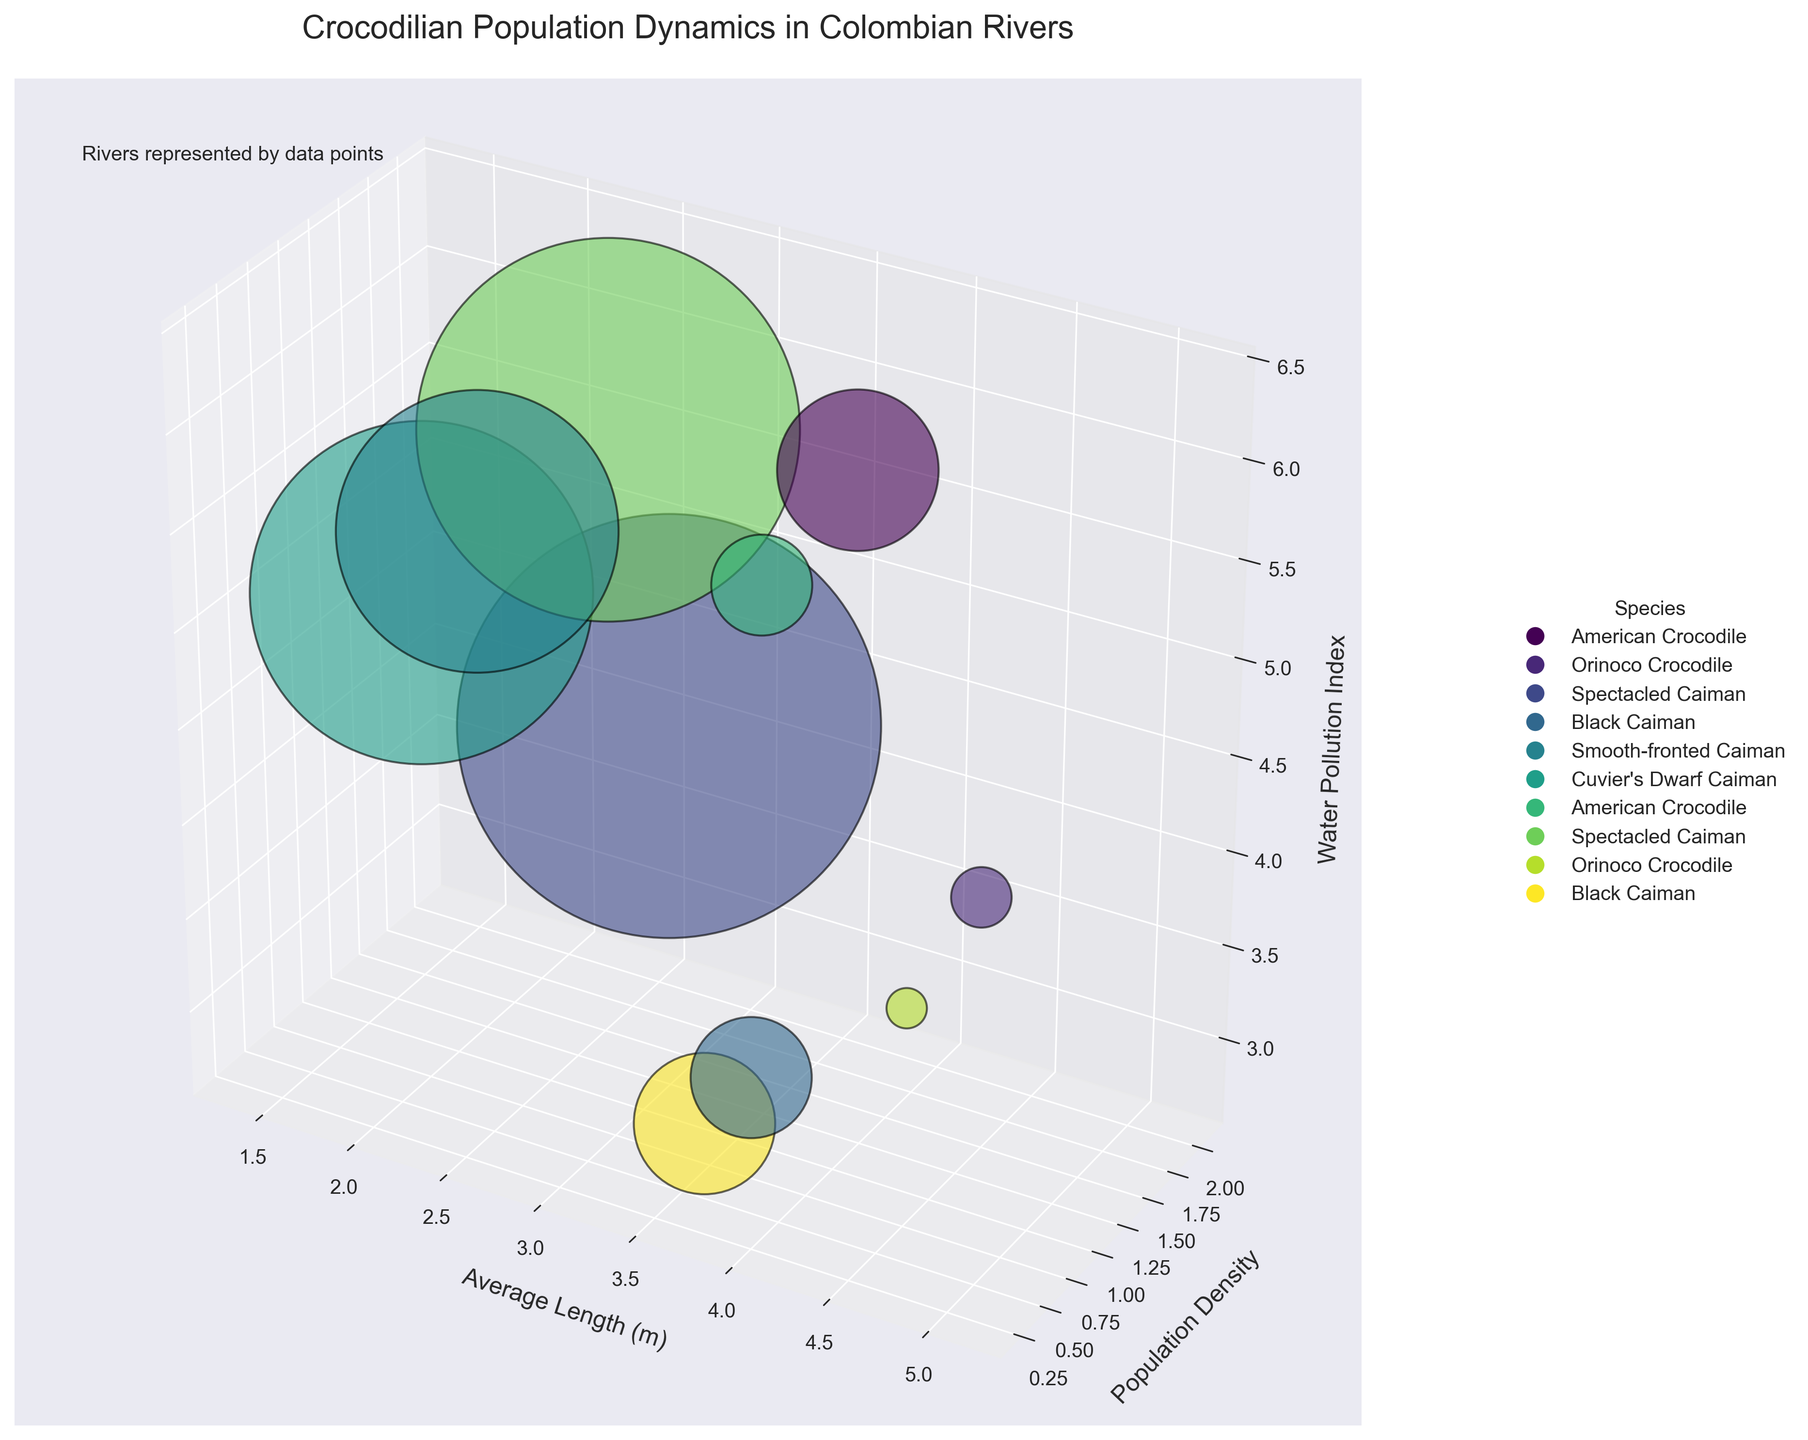What's the title of the figure? The title is located at the top of the figure. It reads "Crocodilian Population Dynamics in Colombian Rivers."
Answer: Crocodilian Population Dynamics in Colombian Rivers How many different species are represented in the figure? By looking at the legend, there are different markers for different species. Counting these gives us the answer.
Answer: 6 Which river has the highest population density of crocodilians? Identify the highest point on the Y-axis (Population Density) and check the corresponding river. The river with a maximum Y value of 2.1 is the Amazonas River.
Answer: Amazonas River Which species has the largest average length, and what is it? Look at the X-axis (Average Length). The maximum point, represented by dots, corresponds to the Orinoco Crocodile. The value is 5.1 meters.
Answer: Orinoco Crocodile, 5.1 meters Compare the population density of the Spectacled Caiman in the Amazonas River and the Atrato River. Which has a higher population density? Locate the Spectacled Caiman's data points for both rivers on the Y-axis and compare them. The Amazonas River has a population density of 2.1, and the Atrato River has 1.9, so the Amazonas River is higher.
Answer: Amazonas River Which two rivers have the lowest water pollution levels? Locate the points along the Z-axis (Water Pollution Index) and identify the lowest values. The values are 2.8 for the Apaporis River and 3.2 for the Caquetá River.
Answer: Apaporis River and Caquetá River If you compare the American Crocodile in the Magdalena River and the Sinú River, which one has a higher water pollution index and by how much? Check the Z-axis values for the Magdalena River and the Sinú River. Magdalena River has 6.3, and Sinú River has 5.8. Subtracting gives 0.5.
Answer: Magdalena River, 0.5 Which species is generally found in rivers with lower pollution indices, and what evidence supports your answer? Analyze the Z-axis (Water Pollution Index) focusing on the species distribution. The Black Caiman is found in Caquetá River (3.2) and Apaporis River (2.8), the lowest indices. This suggests this species favors less polluted rivers.
Answer: Black Caiman Sum up the population densities of Cuvier's Dwarf Caiman and Smooth-fronted Caiman. What do you get? Find the Y-axis values for both species. Cuvier's Dwarf Caiman: 1.7, Smooth-fronted Caiman: 1.4. Summing them up gives 1.7 + 1.4 = 3.1.
Answer: 3.1 